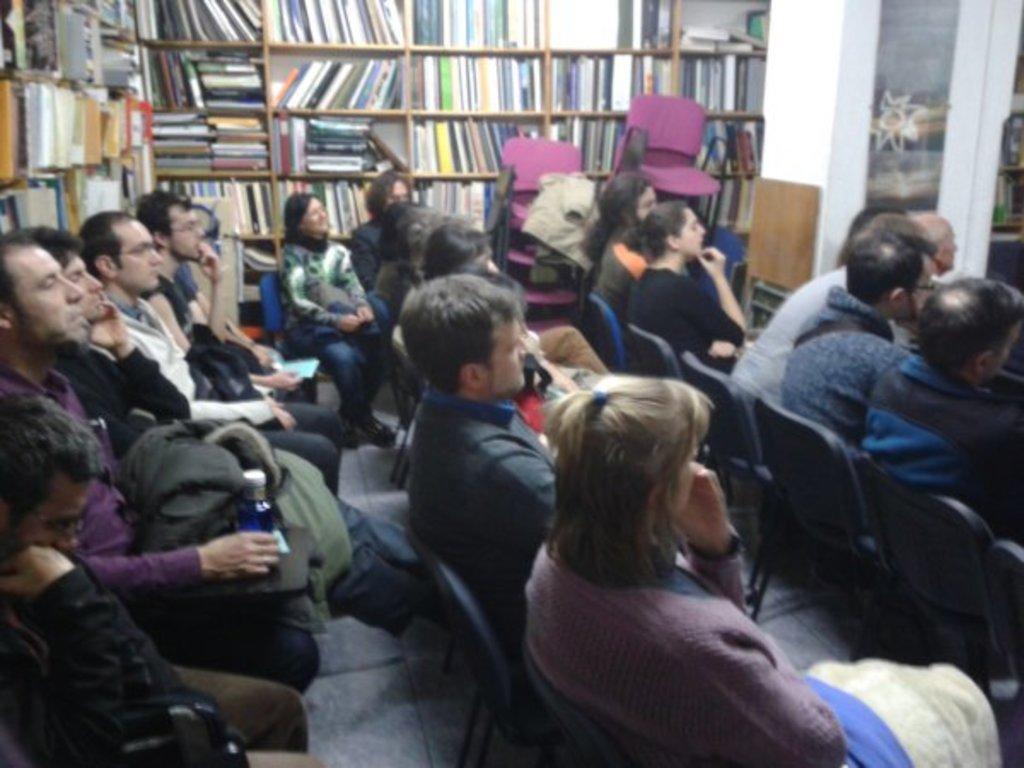In one or two sentences, can you explain what this image depicts? In this image there are group of people sitting on the chairs, and in the background there are books in the book rack , and there are chairs. 